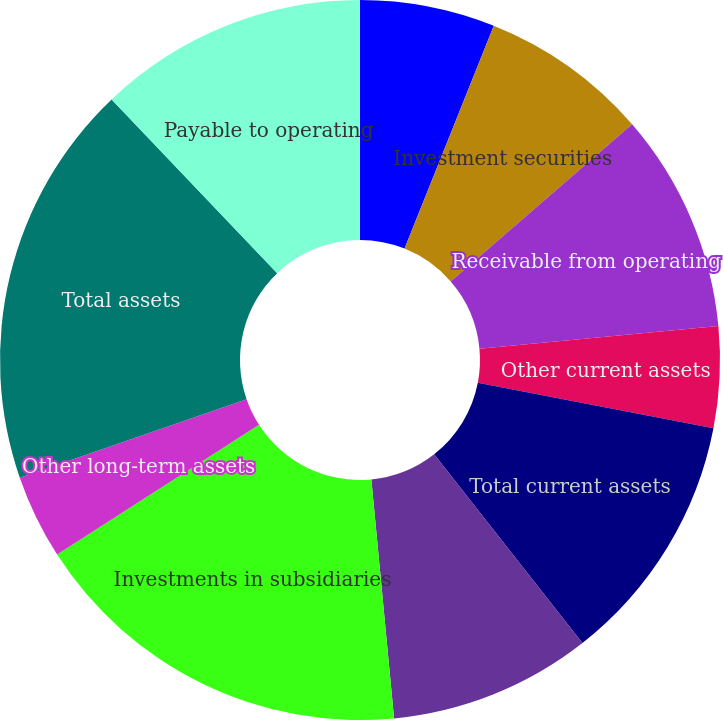Convert chart. <chart><loc_0><loc_0><loc_500><loc_500><pie_chart><fcel>Cash and cash equivalents<fcel>Investment securities<fcel>Receivable from operating<fcel>Other current assets<fcel>Total current assets<fcel>Property and equipment net<fcel>Investments in subsidiaries<fcel>Other long-term assets<fcel>Total assets<fcel>Payable to operating<nl><fcel>6.06%<fcel>7.58%<fcel>9.85%<fcel>4.55%<fcel>11.36%<fcel>9.09%<fcel>17.42%<fcel>3.79%<fcel>18.18%<fcel>12.12%<nl></chart> 